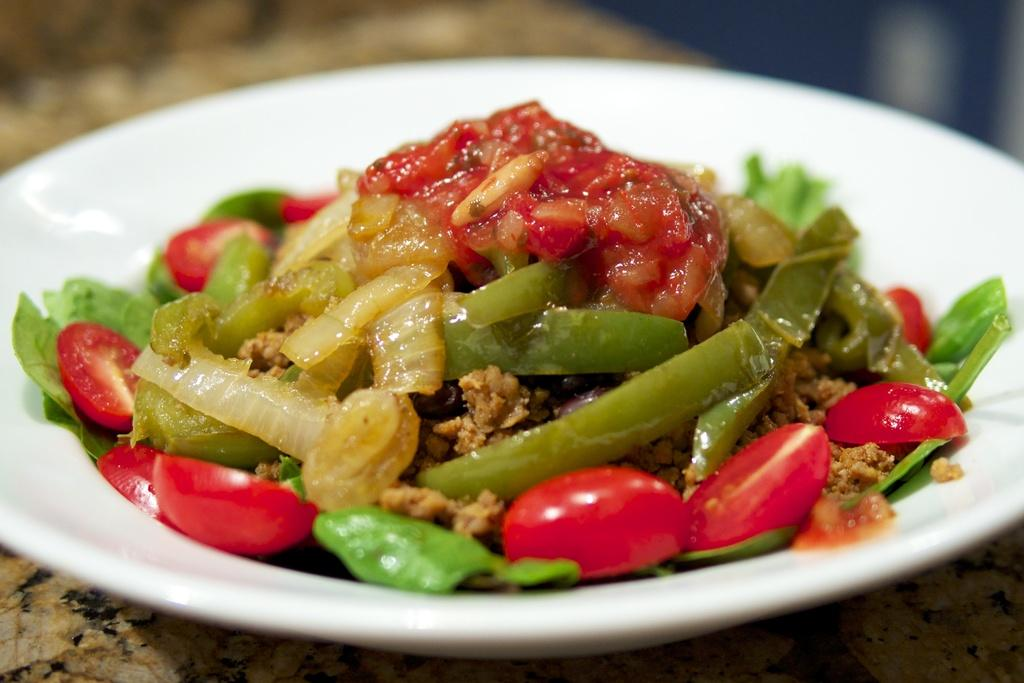What is on the plate that is visible in the image? There is a plate with food items in the image. What specific food items can be seen on the plate? The food items include onion and tomato pieces. Where is the plate located in the image? The plate is placed on a platform. What color is the flag that is being waved in the image? There is no flag present in the image; it only features a plate with food items. 